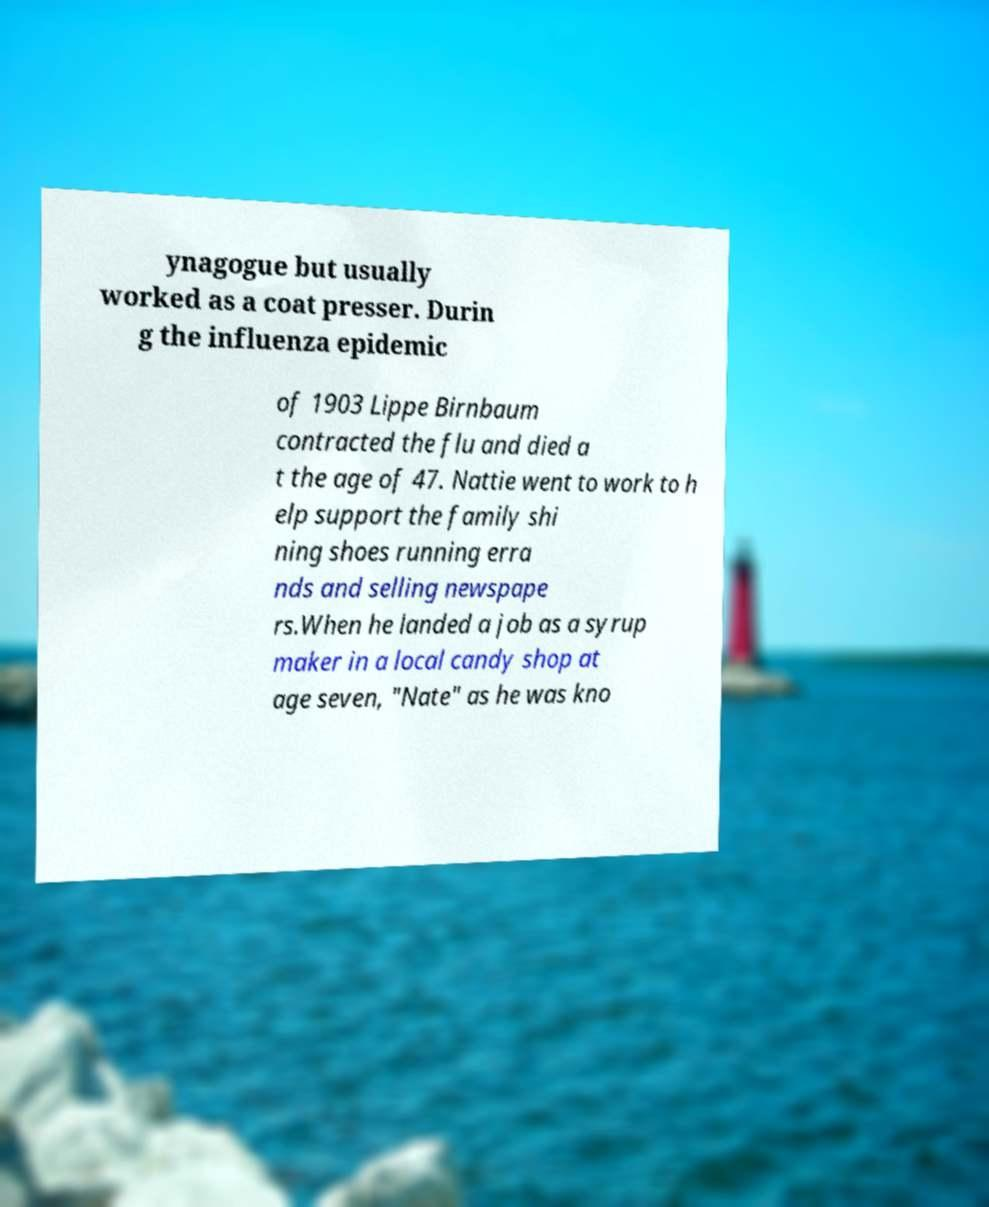Please read and relay the text visible in this image. What does it say? ynagogue but usually worked as a coat presser. Durin g the influenza epidemic of 1903 Lippe Birnbaum contracted the flu and died a t the age of 47. Nattie went to work to h elp support the family shi ning shoes running erra nds and selling newspape rs.When he landed a job as a syrup maker in a local candy shop at age seven, "Nate" as he was kno 